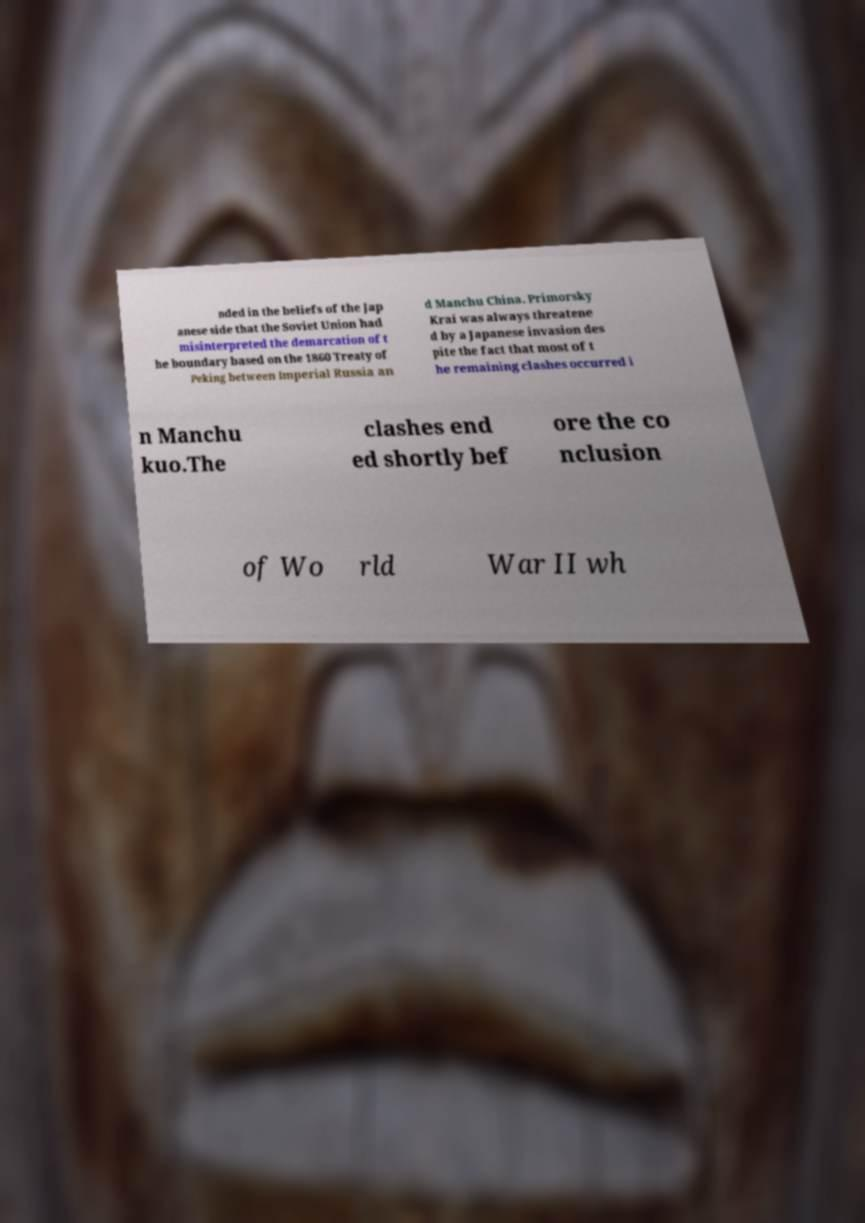For documentation purposes, I need the text within this image transcribed. Could you provide that? nded in the beliefs of the Jap anese side that the Soviet Union had misinterpreted the demarcation of t he boundary based on the 1860 Treaty of Peking between Imperial Russia an d Manchu China. Primorsky Krai was always threatene d by a Japanese invasion des pite the fact that most of t he remaining clashes occurred i n Manchu kuo.The clashes end ed shortly bef ore the co nclusion of Wo rld War II wh 